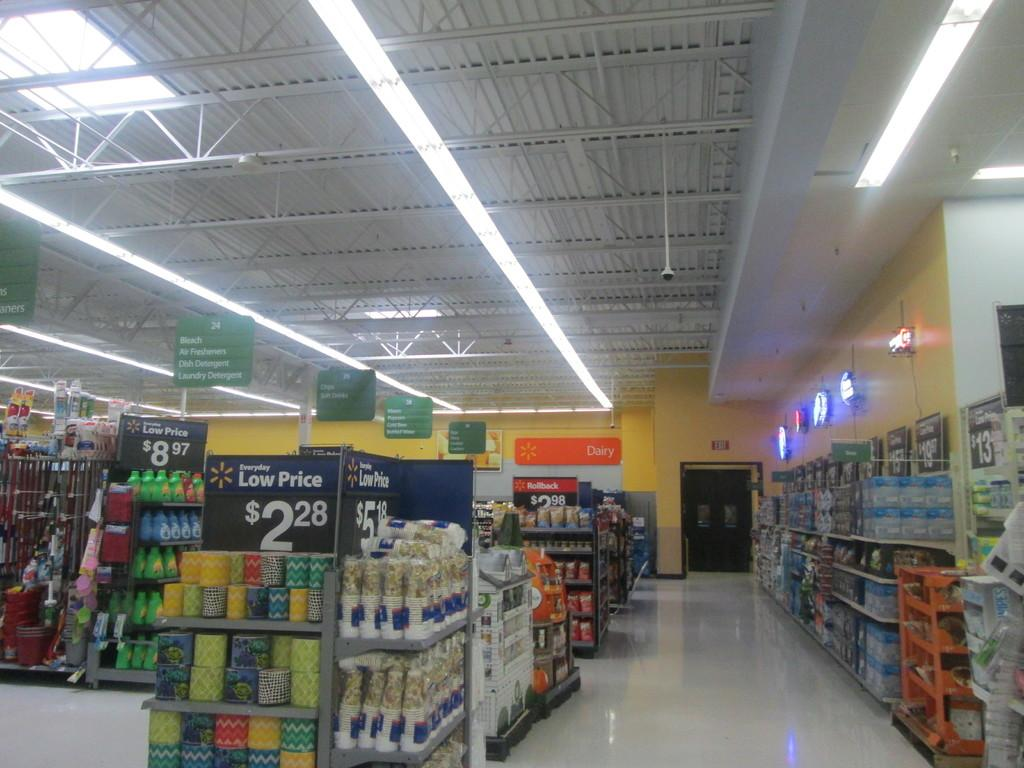Provide a one-sentence caption for the provided image. The inside of a Walmart shows a sale for $2.88. 